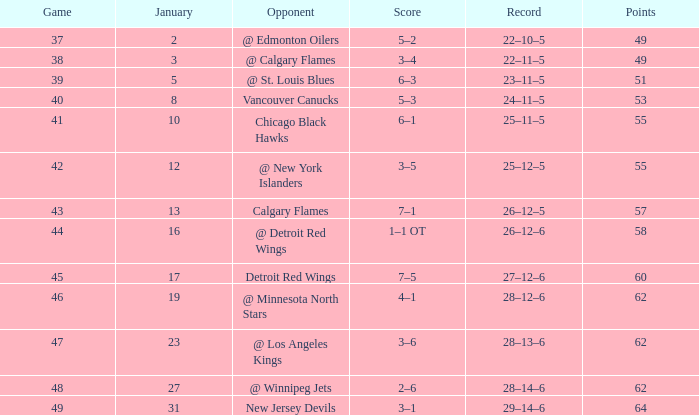How many Games have a Score of 2–6, and Points larger than 62? 0.0. 